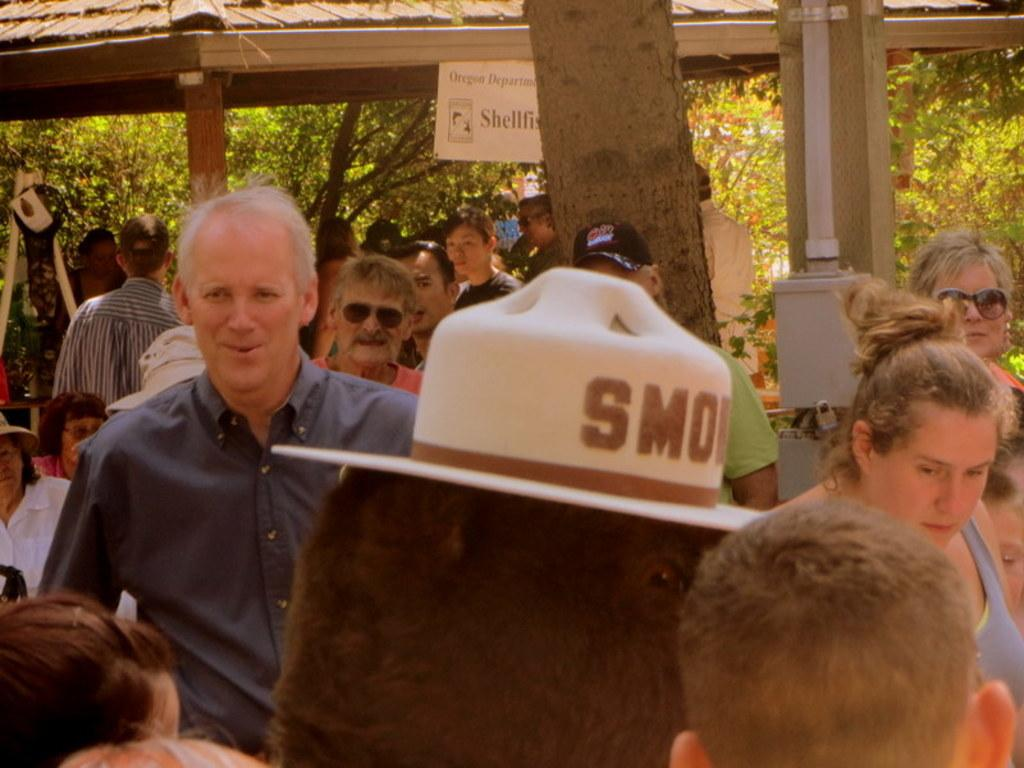What is happening in the image? There is a group of people standing in the image. What can be seen in the background of the image? There is a roof, trees, and a board with writing visible in the background of the image. What type of grape is being held by the person on the left in the image? There is no grape present in the image, and no one is holding a grape. 